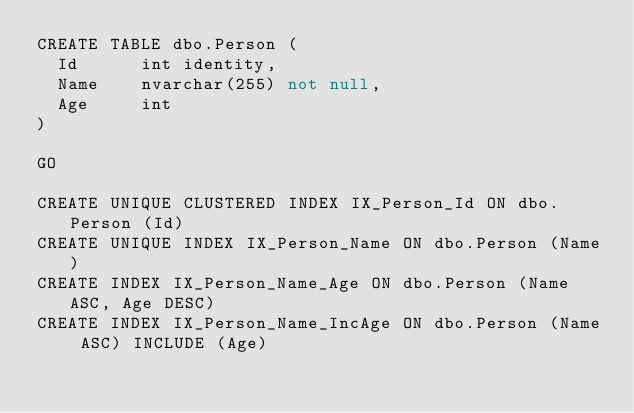<code> <loc_0><loc_0><loc_500><loc_500><_SQL_>CREATE TABLE dbo.Person (
	Id 			int	identity,
	Name 		nvarchar(255) not null,
	Age			int
)

GO

CREATE UNIQUE CLUSTERED INDEX IX_Person_Id ON dbo.Person (Id)
CREATE UNIQUE INDEX IX_Person_Name ON dbo.Person (Name)
CREATE INDEX IX_Person_Name_Age ON dbo.Person (Name ASC, Age DESC)
CREATE INDEX IX_Person_Name_IncAge ON dbo.Person (Name ASC) INCLUDE (Age)</code> 